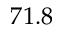<formula> <loc_0><loc_0><loc_500><loc_500>7 1 . 8</formula> 